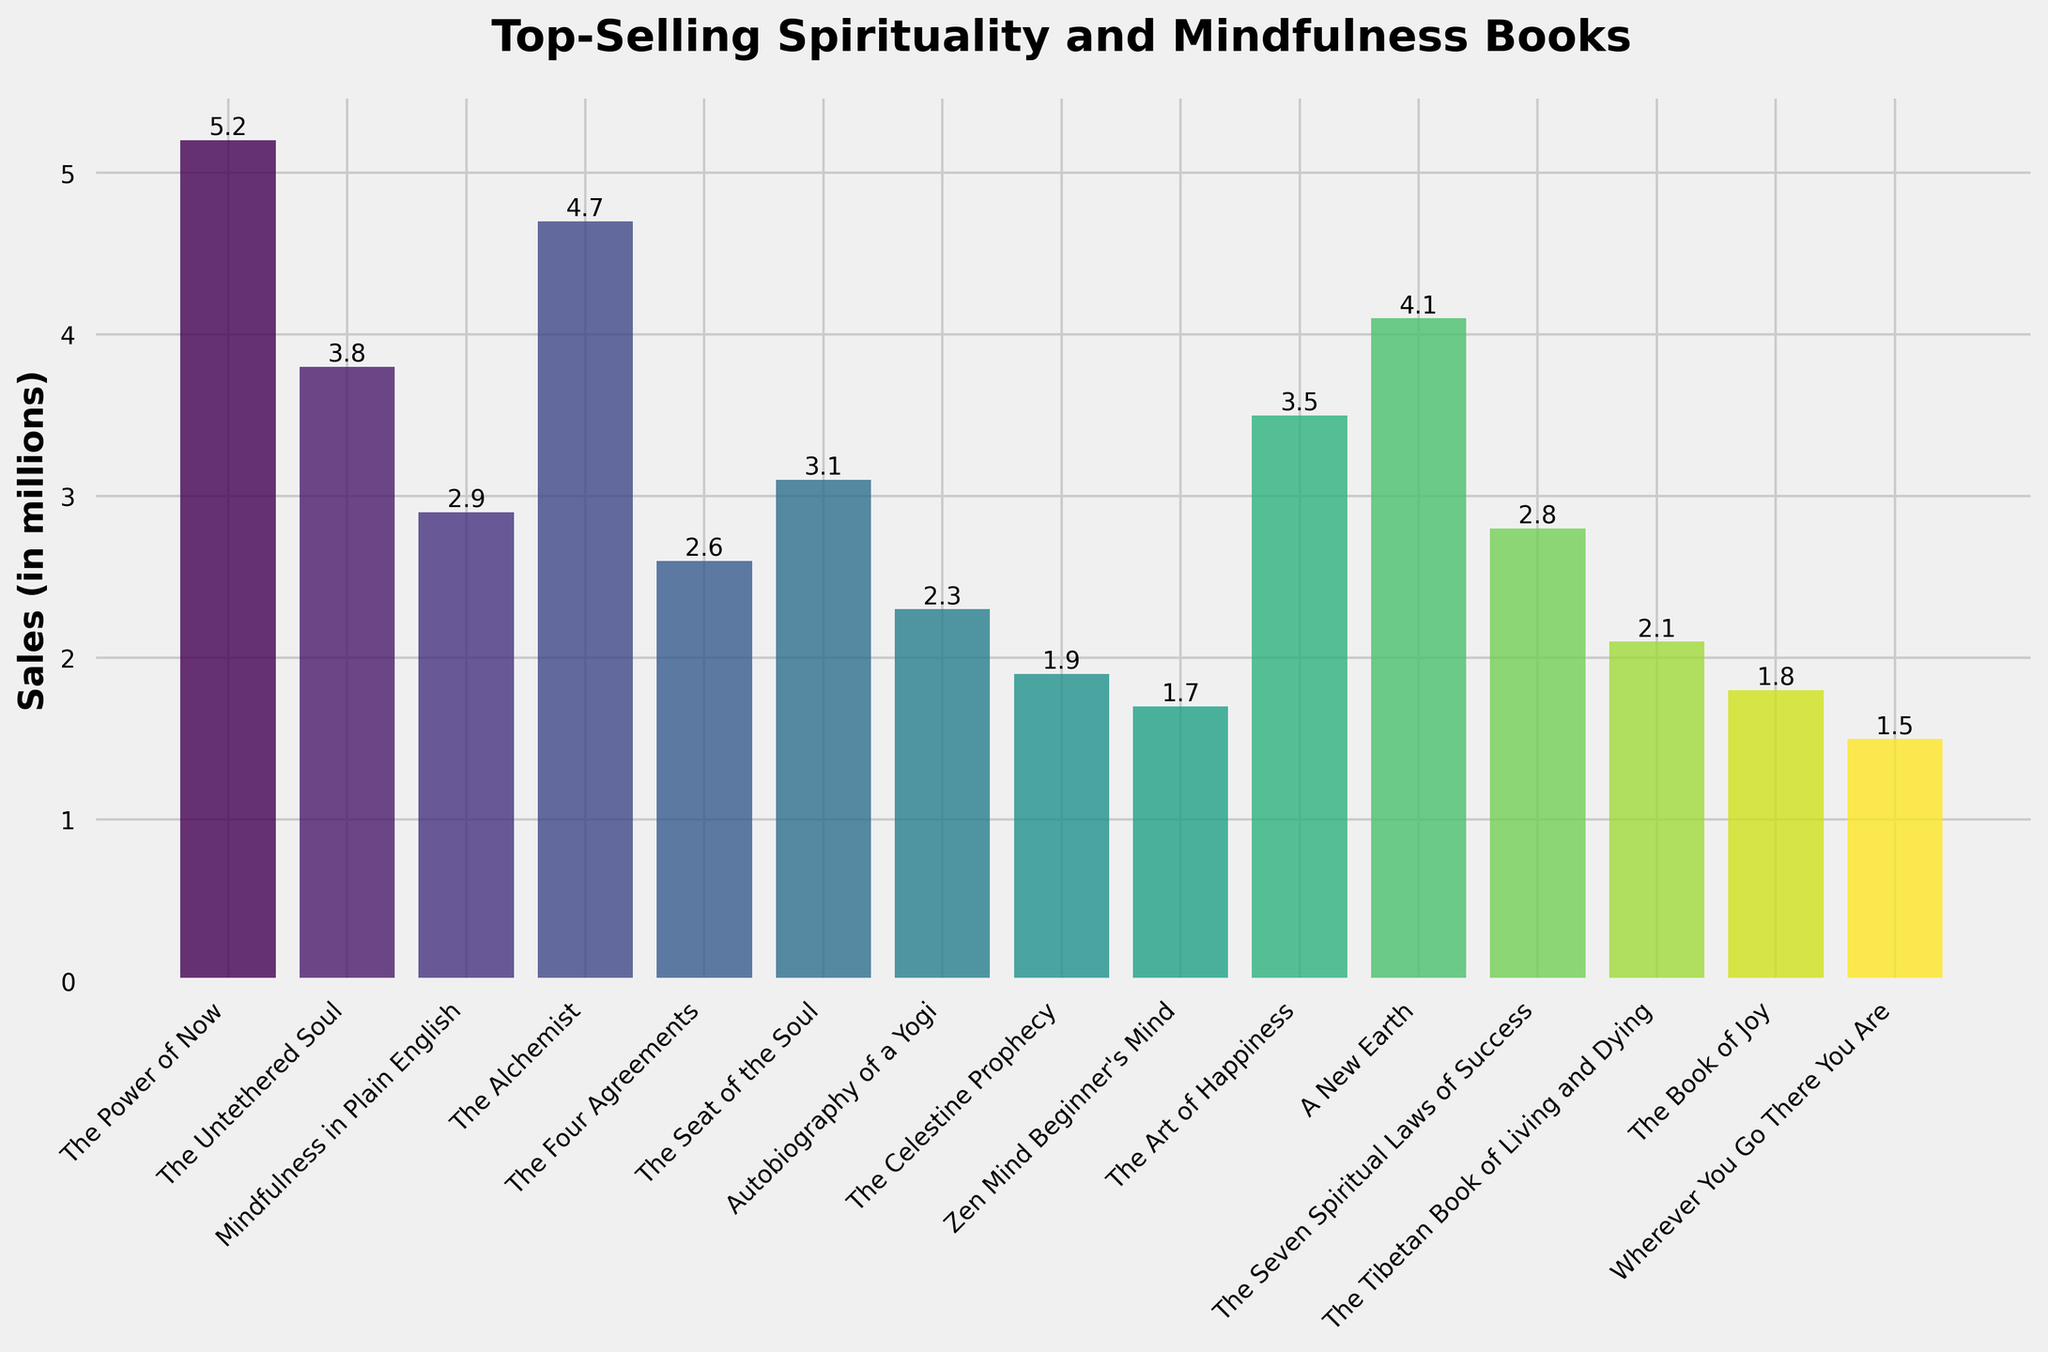Which book has the highest sales? By observing the heights of the bars, "The Power of Now" has the tallest bar indicating the highest sales among the books listed.
Answer: The Power of Now What is the total combined sales of "The Power of Now" and "The Alchemist"? Sum the heights of the bars for "The Power of Now" and "The Alchemist". Sales for "The Power of Now" is 5.2 million, and for "The Alchemist" is 4.7 million. Therefore, 5.2 + 4.7 = 9.9 million.
Answer: 9.9 million Which book has lower sales: "Zen Mind Beginner's Mind" or "The Celestine Prophecy"? Compare the heights of the bars for "Zen Mind Beginner's Mind" and "The Celestine Prophecy". "Zen Mind Beginner's Mind" has a shorter bar, indicating lower sales.
Answer: Zen Mind Beginner's Mind What is the average sales of "A New Earth," "The Art of Happiness," and "The Seat of the Soul"? First, sum the sales of the three books: "A New Earth" (4.1 million), "The Art of Happiness" (3.5 million), and "The Seat of the Soul" (3.1 million). The sum is 4.1 + 3.5 + 3.1 = 10.7 million. Then, divide by 3 to find the average: 10.7 / 3 ≈ 3.57 million.
Answer: 3.57 million Which book's sales are closest to 3 million? By scanning the height of the bars, "The Seat of the Soul" has sales closest to 3 million with 3.1 million.
Answer: The Seat of the Soul How much more did "The Untethered Soul" sell compared to "The Four Agreements"? Find the difference in height between "The Untethered Soul" and "The Four Agreements". "The Untethered Soul" sold 3.8 million and "The Four Agreements" sold 2.6 million. Therefore, 3.8 - 2.6 = 1.2 million more.
Answer: 1.2 million What is the second highest selling book? The second highest bar in the figure corresponds to "The Alchemist" with 4.7 million sales, right after "The Power of Now".
Answer: The Alchemist Which book has the lowest sales, and what is the exact amount? The shortest bar represents the book with the lowest sales. "Wherever You Go There You Are" has the shortest bar, indicating sales of 1.5 million.
Answer: Wherever You Go There You Are, 1.5 million What is the difference in sales between "The Power of Now" and "A New Earth"? Subtract the sales of "A New Earth" from "The Power of Now". "The Power of Now" has sales of 5.2 million and "A New Earth" has 4.1 million. Therefore, 5.2 - 4.1 = 1.1 million difference.
Answer: 1.1 million 